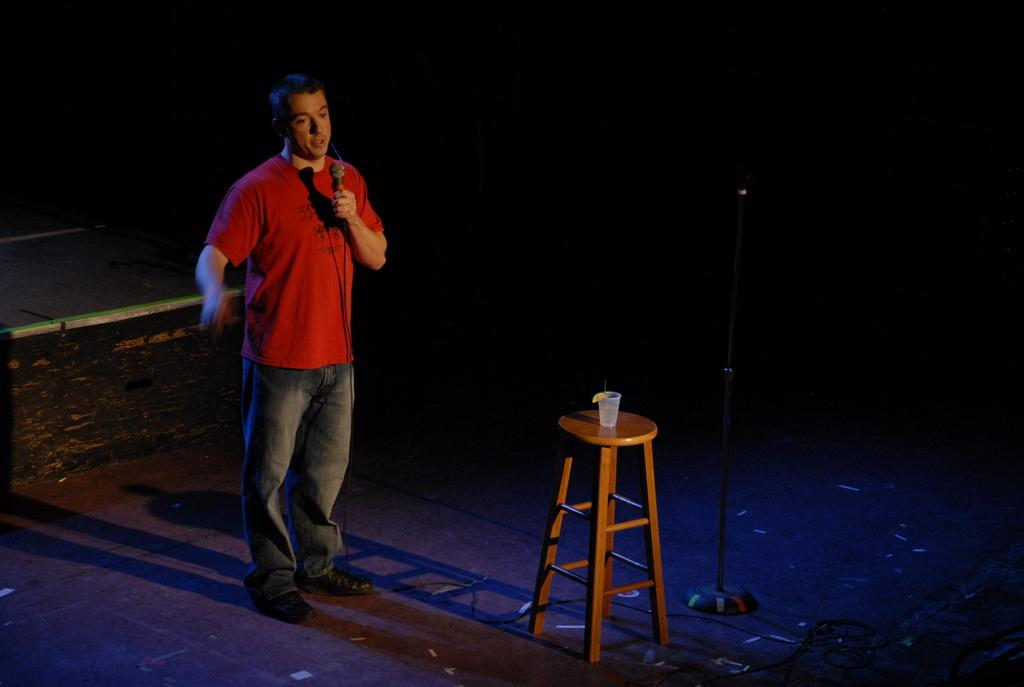What is the person in the image holding? The person is holding a mic. What object can be seen on the table in the image? There is a glass on the table. What is the purpose of the mic stand in the image? The mic stand is used to hold the mic. What part of the room is visible at the bottom of the image? The floor is visible at the bottom of the image. What type of rhythm can be heard coming from the hole in the image? There is no hole present in the image, so no rhythm can be heard. 